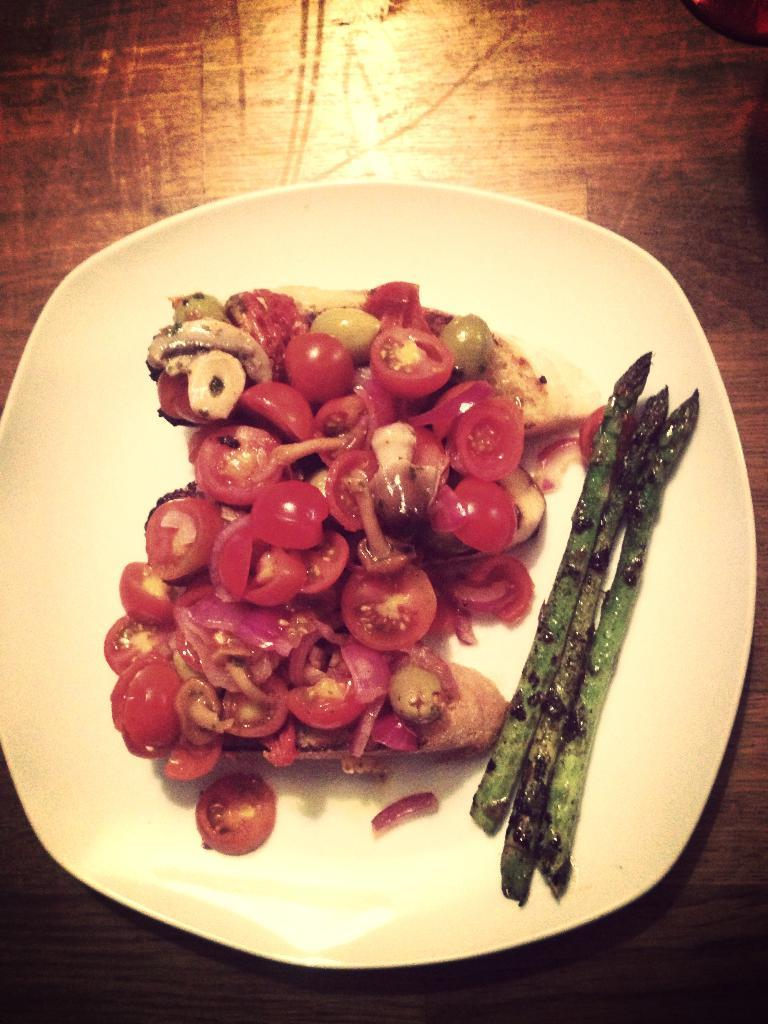What color is the plate visible in the image? The plate is white. What type of surface is the plate placed on? The plate is placed on a wooden surface. What type of food can be seen on the plate? There are tomato pieces and asparagus on the plate. Are there any other food items on the plate besides tomatoes and asparagus? Yes, there are other unspecified food items on the plate. Is the person driving the car visible in the image? There is no car or person driving a car present in the image. What type of yarn is being used to knit the sweater in the image? There is no sweater or yarn present in the image. 